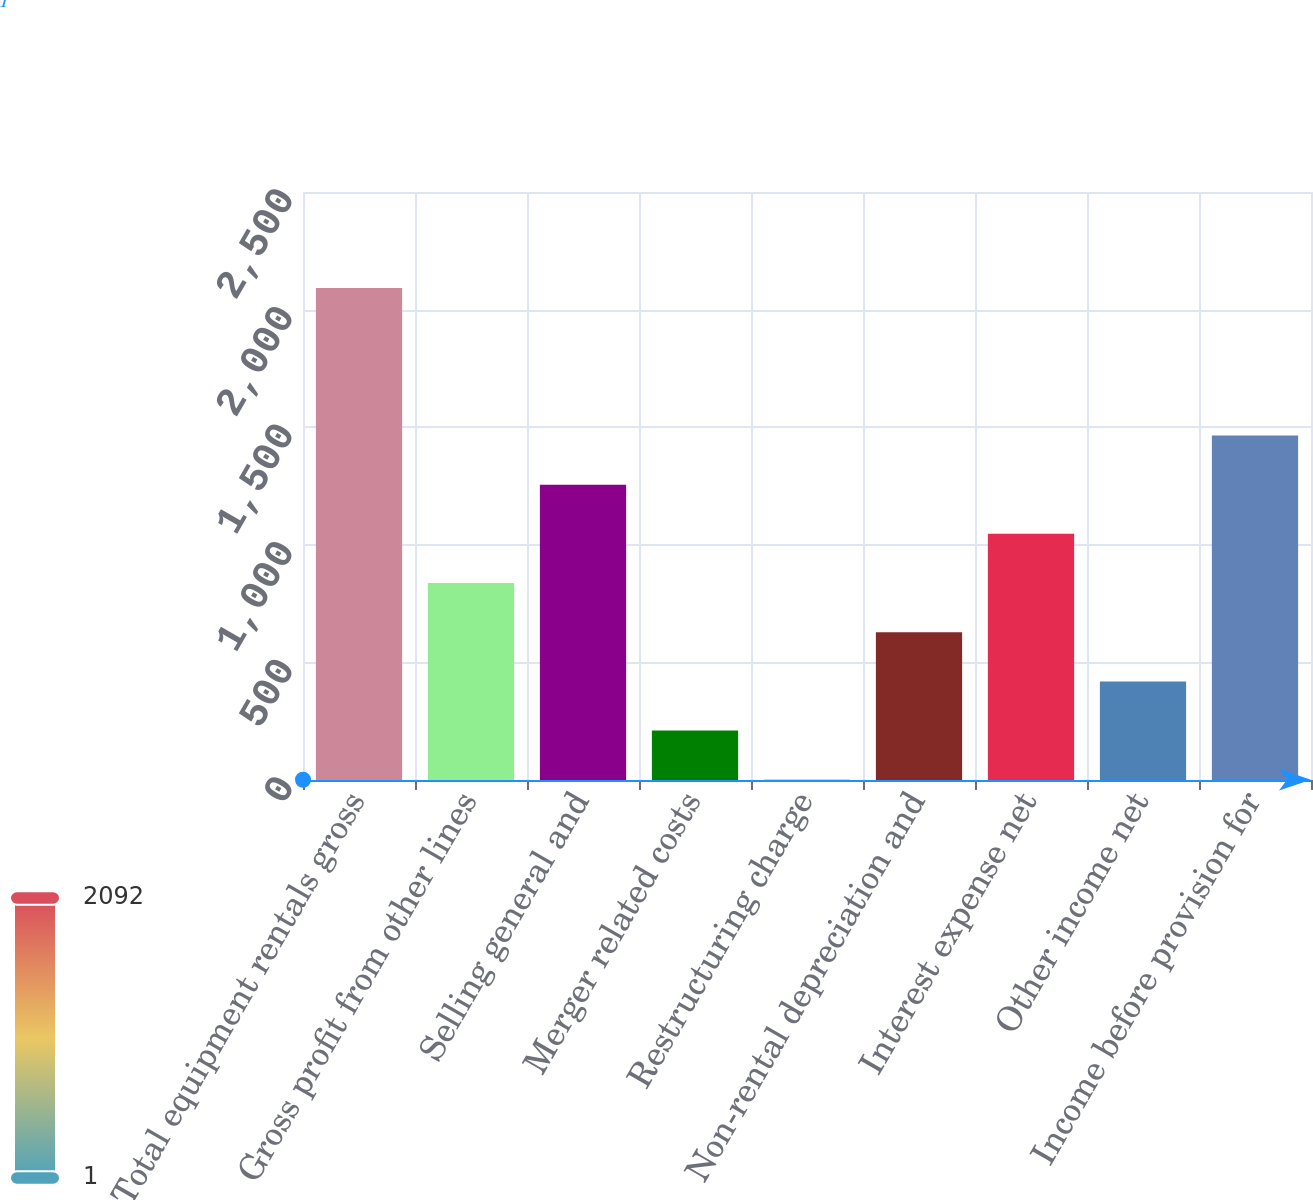<chart> <loc_0><loc_0><loc_500><loc_500><bar_chart><fcel>Total equipment rentals gross<fcel>Gross profit from other lines<fcel>Selling general and<fcel>Merger related costs<fcel>Restructuring charge<fcel>Non-rental depreciation and<fcel>Interest expense net<fcel>Other income net<fcel>Income before provision for<nl><fcel>2092<fcel>837.4<fcel>1255.6<fcel>210.1<fcel>1<fcel>628.3<fcel>1046.5<fcel>419.2<fcel>1464.7<nl></chart> 